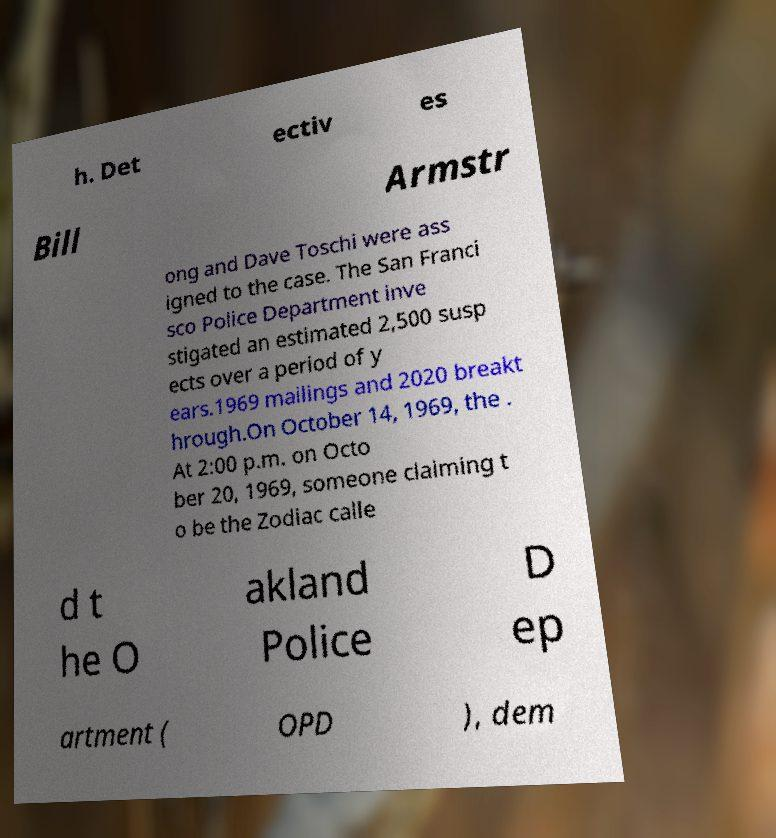Can you accurately transcribe the text from the provided image for me? h. Det ectiv es Bill Armstr ong and Dave Toschi were ass igned to the case. The San Franci sco Police Department inve stigated an estimated 2,500 susp ects over a period of y ears.1969 mailings and 2020 breakt hrough.On October 14, 1969, the . At 2:00 p.m. on Octo ber 20, 1969, someone claiming t o be the Zodiac calle d t he O akland Police D ep artment ( OPD ), dem 